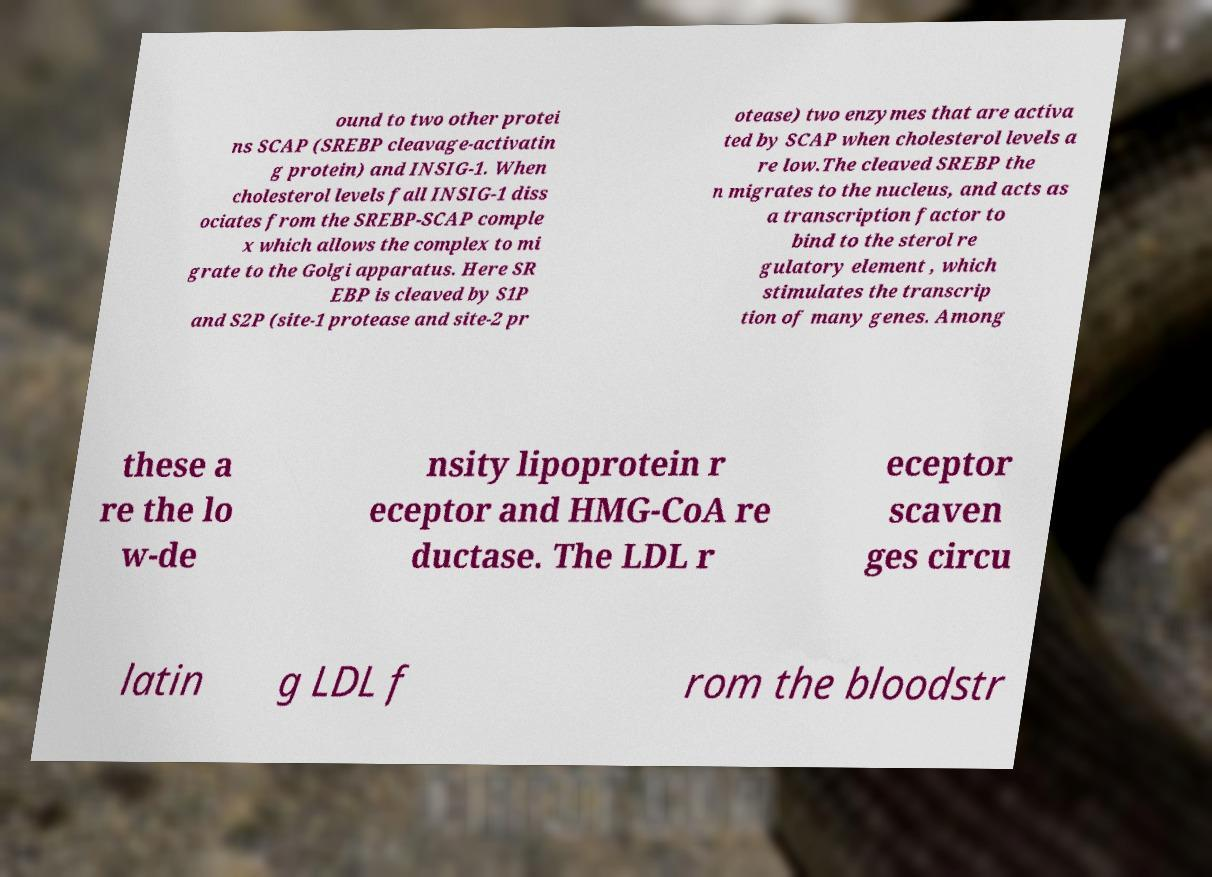Can you read and provide the text displayed in the image?This photo seems to have some interesting text. Can you extract and type it out for me? ound to two other protei ns SCAP (SREBP cleavage-activatin g protein) and INSIG-1. When cholesterol levels fall INSIG-1 diss ociates from the SREBP-SCAP comple x which allows the complex to mi grate to the Golgi apparatus. Here SR EBP is cleaved by S1P and S2P (site-1 protease and site-2 pr otease) two enzymes that are activa ted by SCAP when cholesterol levels a re low.The cleaved SREBP the n migrates to the nucleus, and acts as a transcription factor to bind to the sterol re gulatory element , which stimulates the transcrip tion of many genes. Among these a re the lo w-de nsity lipoprotein r eceptor and HMG-CoA re ductase. The LDL r eceptor scaven ges circu latin g LDL f rom the bloodstr 